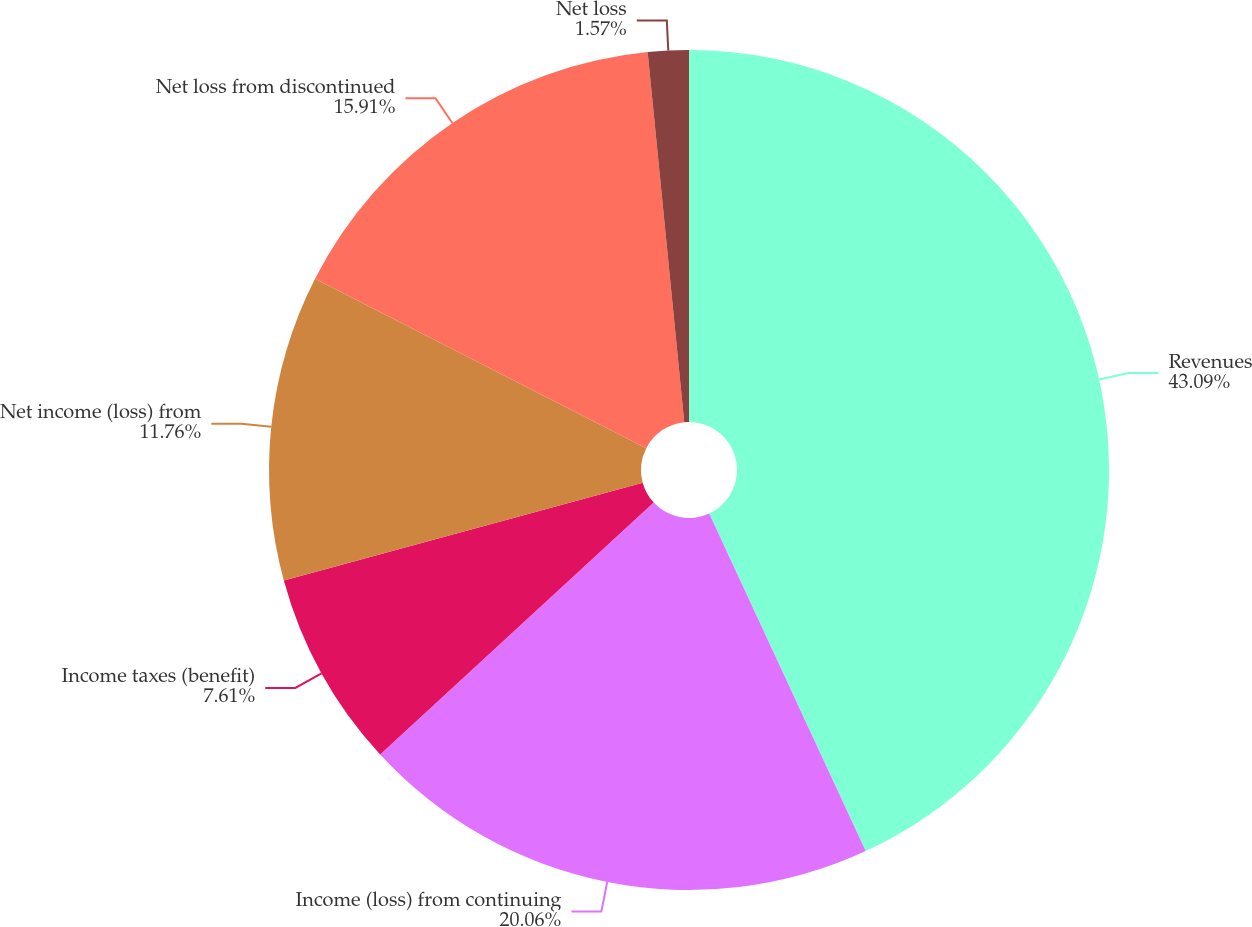Convert chart to OTSL. <chart><loc_0><loc_0><loc_500><loc_500><pie_chart><fcel>Revenues<fcel>Income (loss) from continuing<fcel>Income taxes (benefit)<fcel>Net income (loss) from<fcel>Net loss from discontinued<fcel>Net loss<nl><fcel>43.09%<fcel>20.06%<fcel>7.61%<fcel>11.76%<fcel>15.91%<fcel>1.57%<nl></chart> 